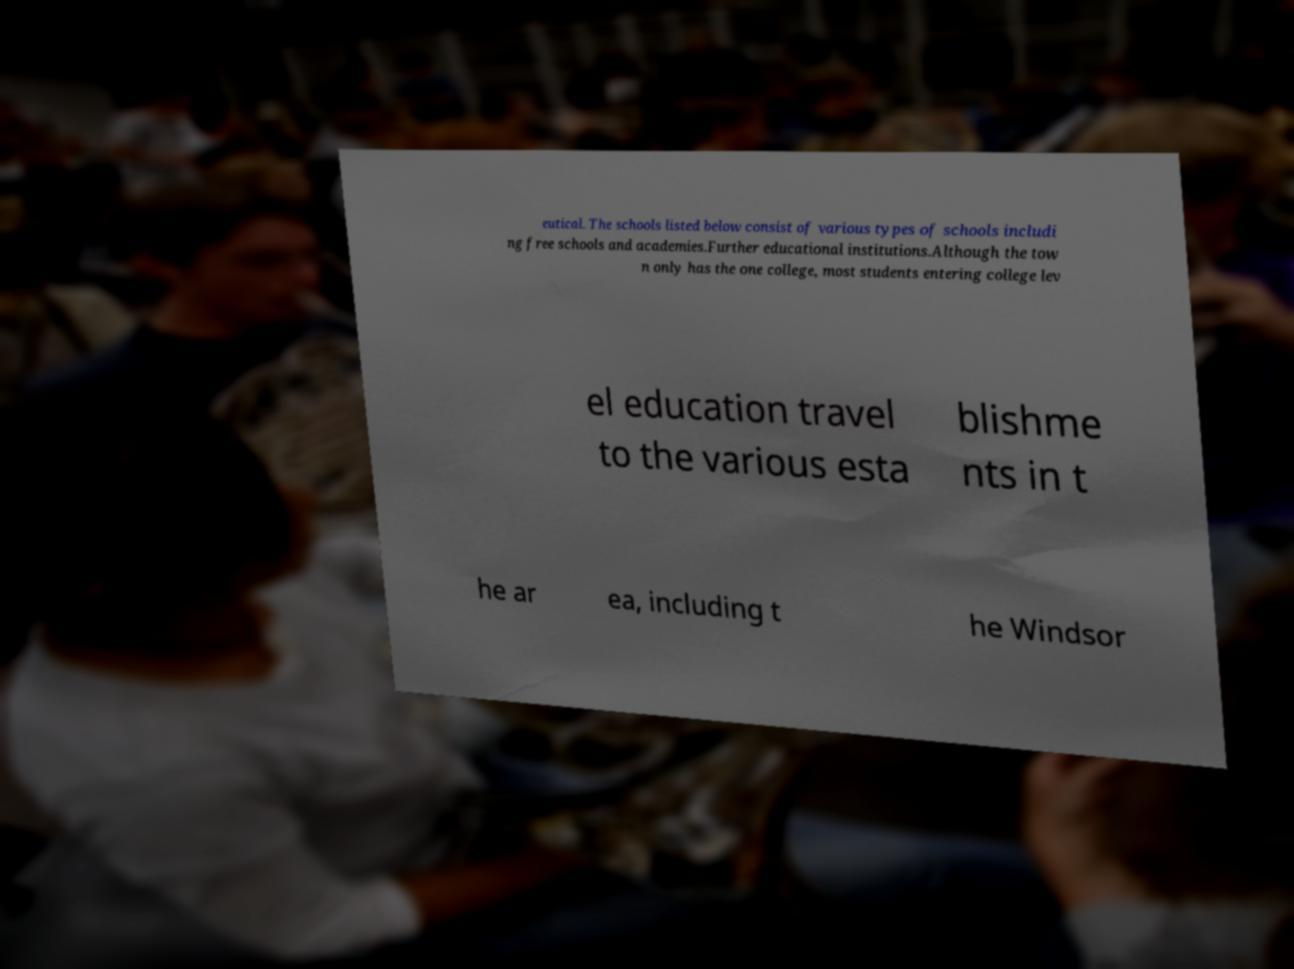What messages or text are displayed in this image? I need them in a readable, typed format. eutical. The schools listed below consist of various types of schools includi ng free schools and academies.Further educational institutions.Although the tow n only has the one college, most students entering college lev el education travel to the various esta blishme nts in t he ar ea, including t he Windsor 